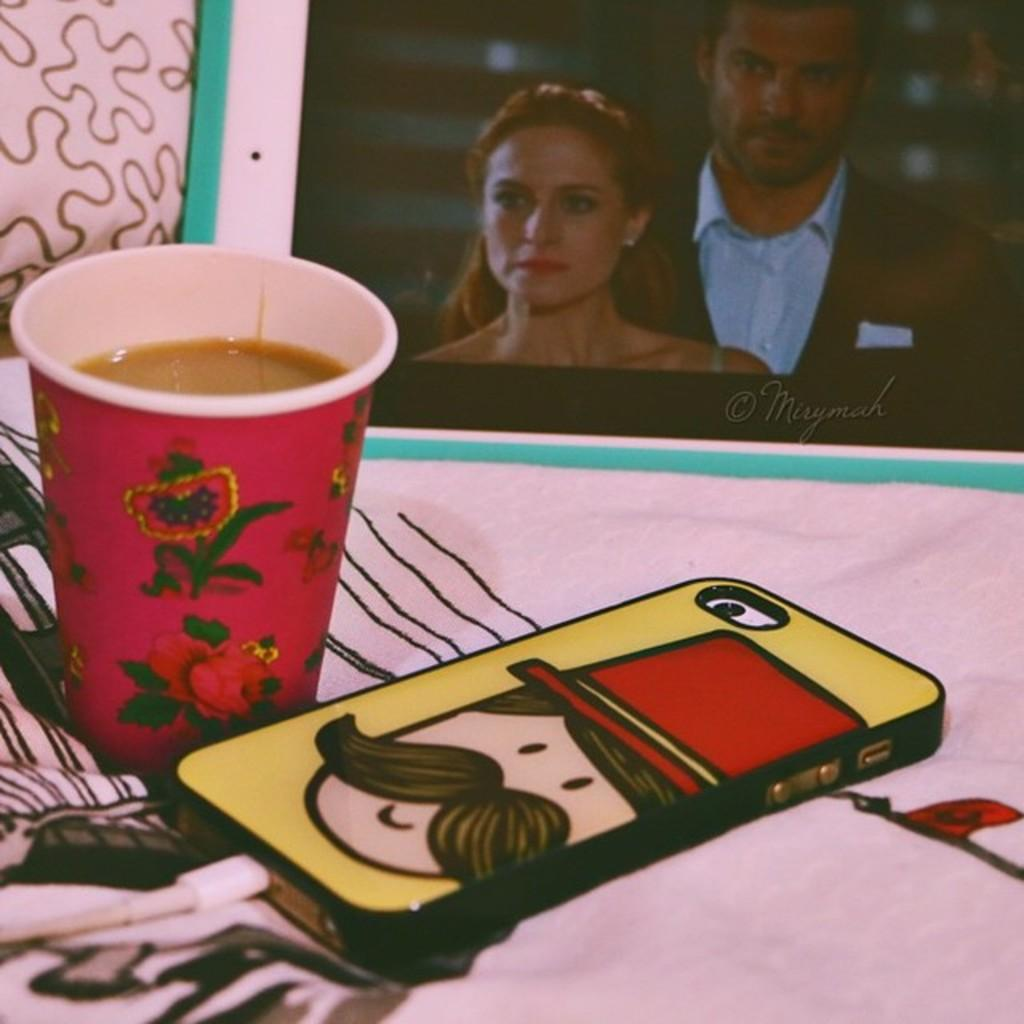What is the main object in the image? There is a cloth in the image. What is placed on the cloth? There is a mobile, a cable, a cup, and a photo frame on the cloth. What is written on the photo frame? There is writing on the photo frame. Can you see a snake slithering on the cloth in the image? No, there is no snake present in the image. What type of ornament is hanging from the mobile in the image? There is no ornament mentioned in the image; only a mobile is described. 